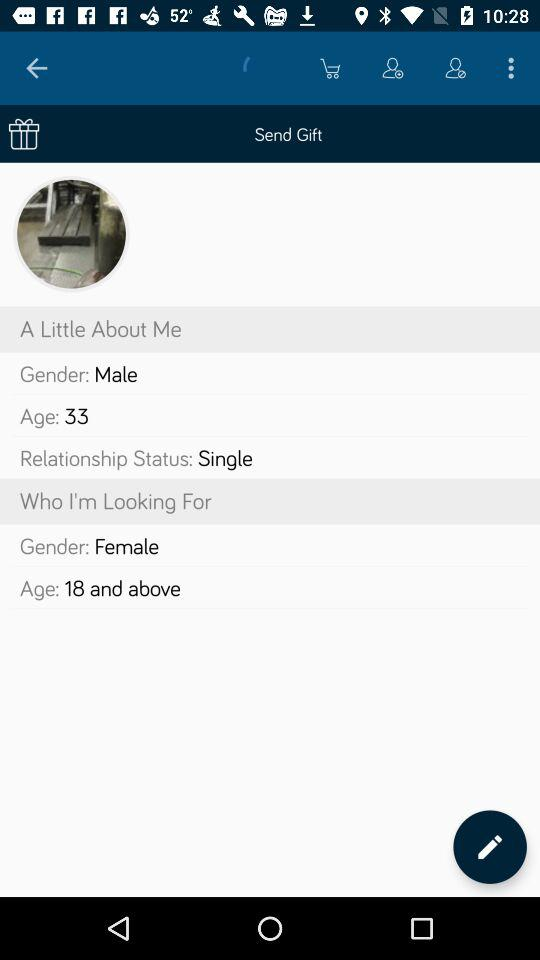What is the age? The age is 33. 